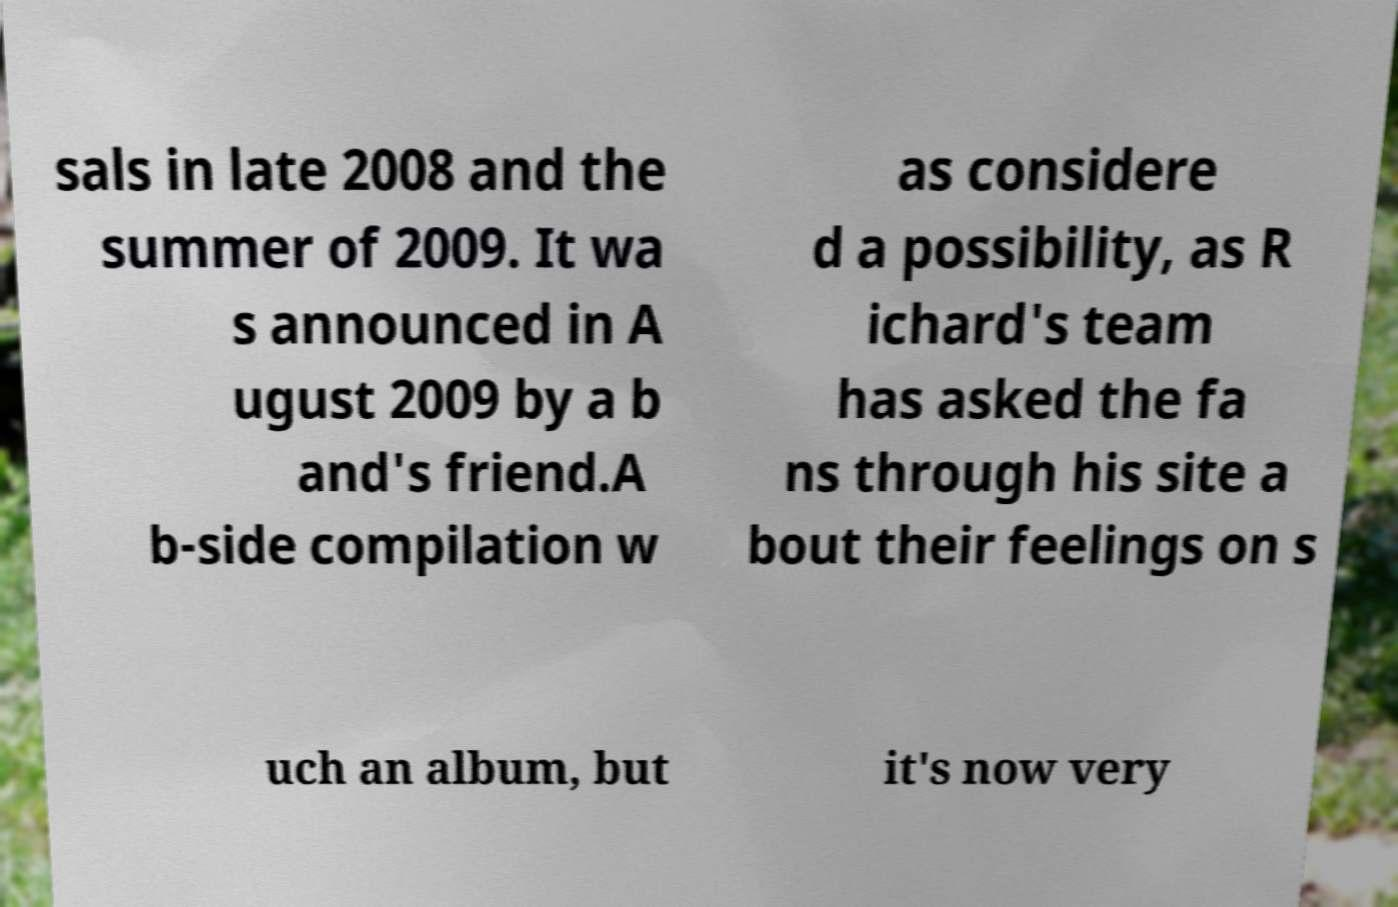Can you accurately transcribe the text from the provided image for me? sals in late 2008 and the summer of 2009. It wa s announced in A ugust 2009 by a b and's friend.A b-side compilation w as considere d a possibility, as R ichard's team has asked the fa ns through his site a bout their feelings on s uch an album, but it's now very 